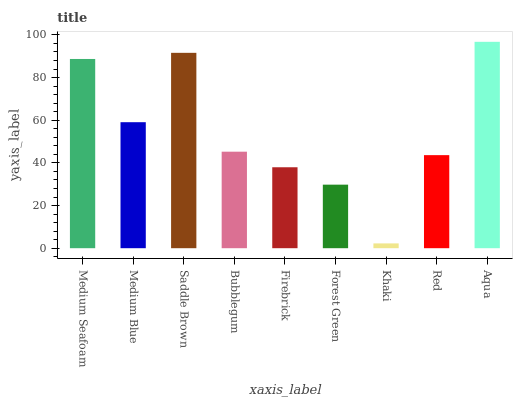Is Khaki the minimum?
Answer yes or no. Yes. Is Aqua the maximum?
Answer yes or no. Yes. Is Medium Blue the minimum?
Answer yes or no. No. Is Medium Blue the maximum?
Answer yes or no. No. Is Medium Seafoam greater than Medium Blue?
Answer yes or no. Yes. Is Medium Blue less than Medium Seafoam?
Answer yes or no. Yes. Is Medium Blue greater than Medium Seafoam?
Answer yes or no. No. Is Medium Seafoam less than Medium Blue?
Answer yes or no. No. Is Bubblegum the high median?
Answer yes or no. Yes. Is Bubblegum the low median?
Answer yes or no. Yes. Is Red the high median?
Answer yes or no. No. Is Saddle Brown the low median?
Answer yes or no. No. 